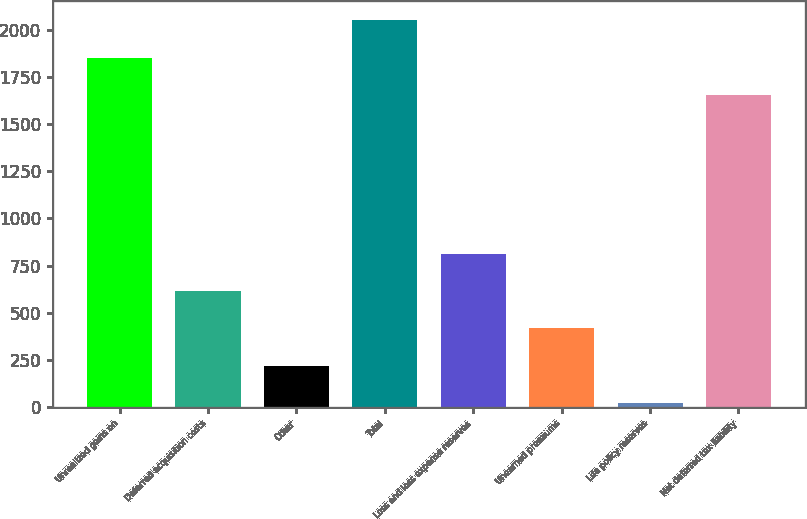Convert chart to OTSL. <chart><loc_0><loc_0><loc_500><loc_500><bar_chart><fcel>Unrealized gains on<fcel>Deferred acquisition costs<fcel>Other<fcel>Total<fcel>Loss and loss expense reserves<fcel>Unearned premiums<fcel>Life policy reserves<fcel>Net deferred tax liability<nl><fcel>1851<fcel>616<fcel>220<fcel>2049<fcel>814<fcel>418<fcel>22<fcel>1653<nl></chart> 